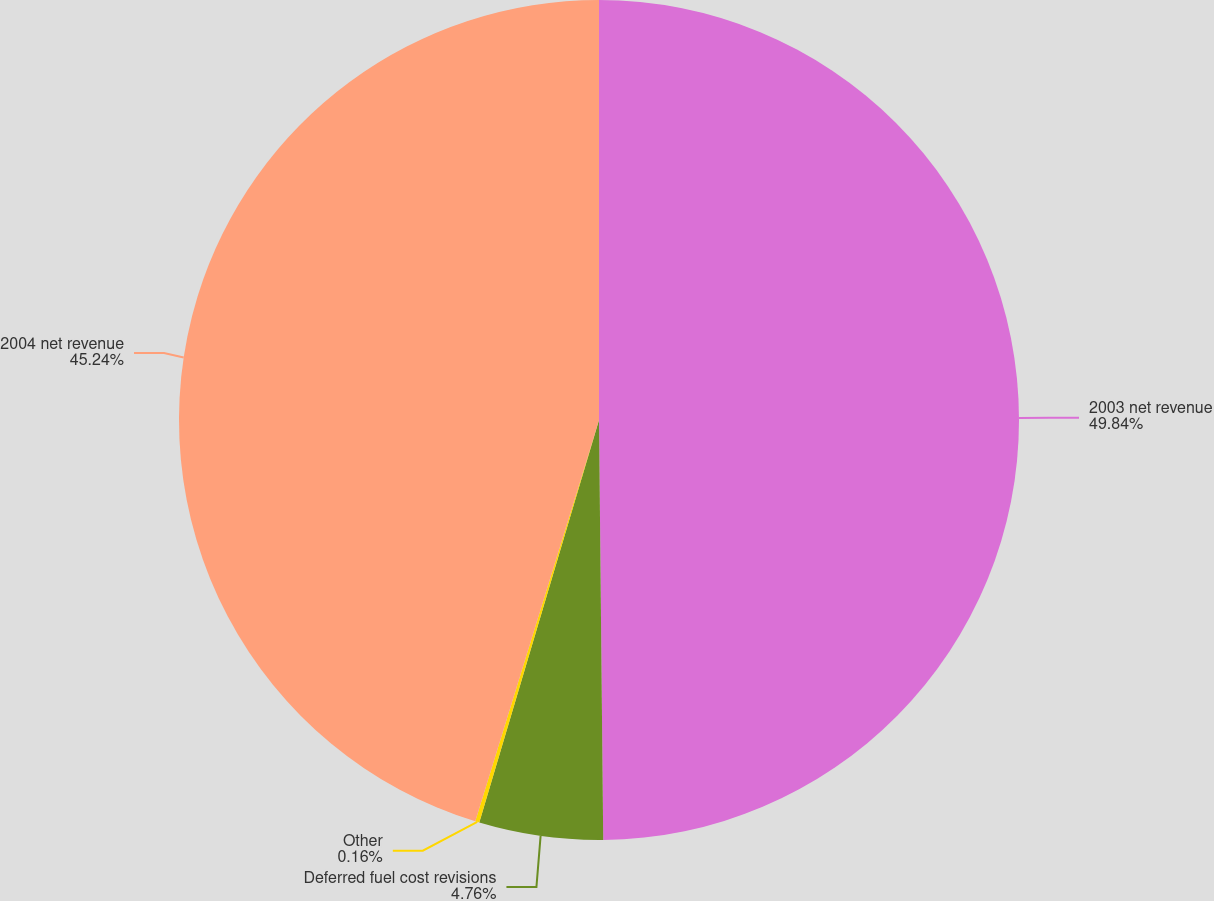Convert chart. <chart><loc_0><loc_0><loc_500><loc_500><pie_chart><fcel>2003 net revenue<fcel>Deferred fuel cost revisions<fcel>Other<fcel>2004 net revenue<nl><fcel>49.84%<fcel>4.76%<fcel>0.16%<fcel>45.24%<nl></chart> 